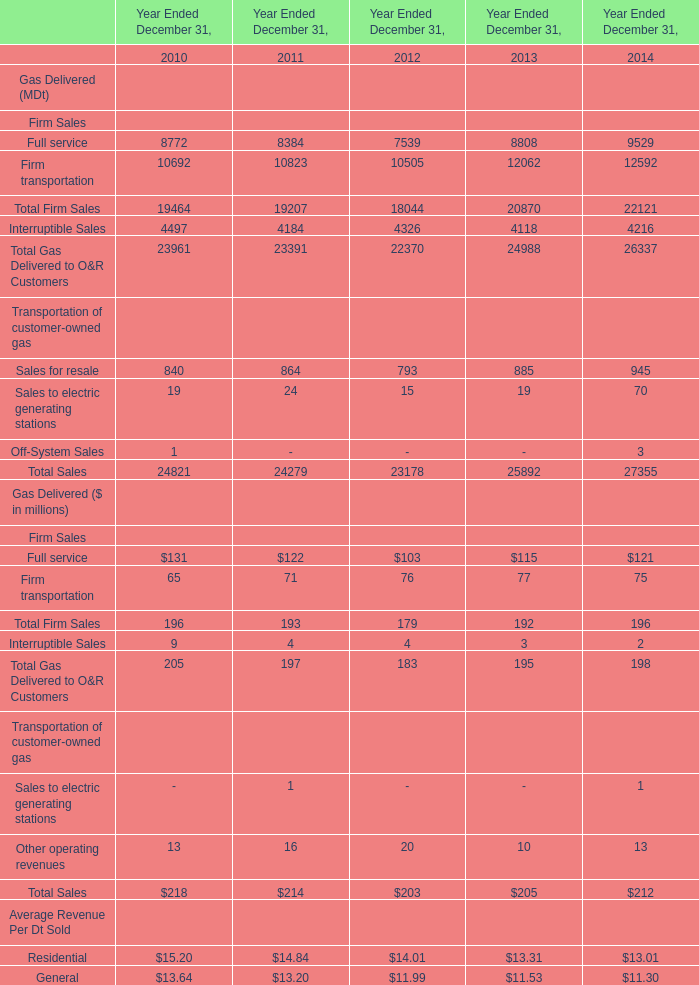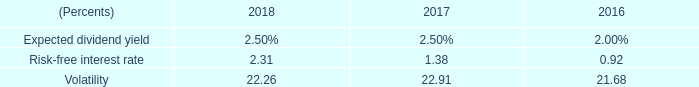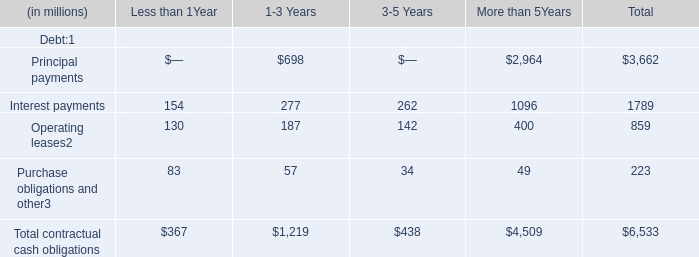If total Firm Sales develops with the same growth rate in 2014, what will it reach in 2015? (in million) 
Computations: ((((196 - 192) / 192) + 1) * 196)
Answer: 200.08333. 